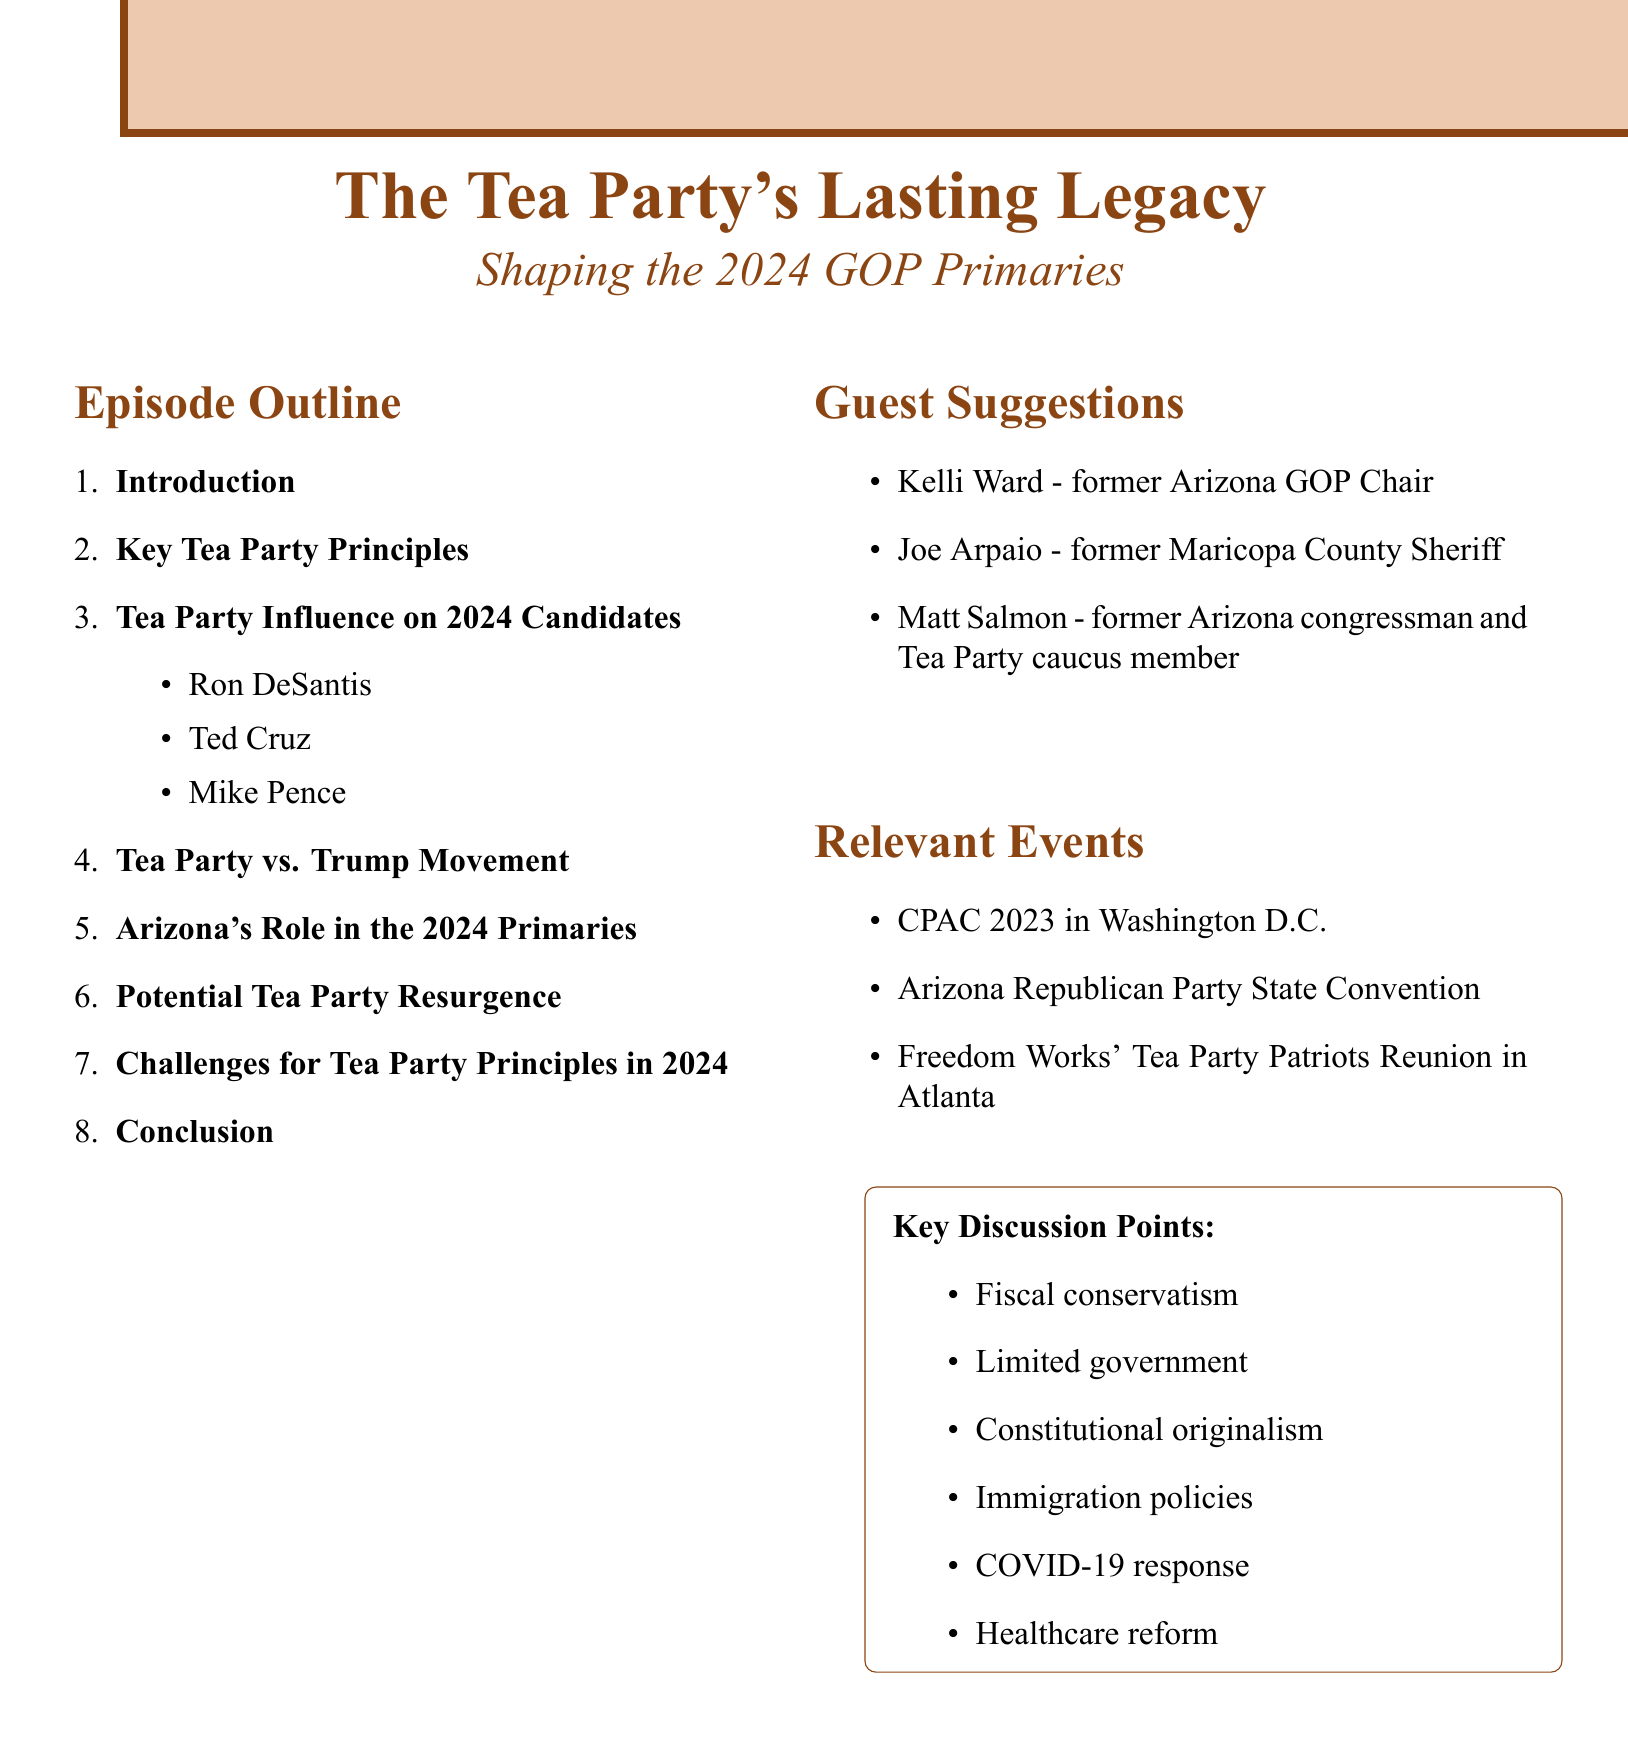What is the title of the podcast? The title of the podcast is presented as the main heading in the document.
Answer: The Tea Party's Lasting Legacy: Shaping the 2024 GOP Primaries How many candidates' influence are covered in the episode? The episode discusses the influence of three specific candidates on Tea Party principles.
Answer: Three Which key principle focuses on government size? The key principle that emphasizes the size of government can be found in the section discussing Tea Party values.
Answer: Limited government What is Arizona's status mentioned in the outline? The outline refers to Arizona's relevance in terms of its electoral role in the primaries.
Answer: Key swing state status Who is suggested as a guest who is a former Maricopa County Sheriff? One of the suggested guests is noted for their past position in local law enforcement.
Answer: Joe Arpaio What are the main themes discussed regarding challenges for the Tea Party in 2024? The themes highlight the difficulties the Tea Party faces as indicated in the relevant section.
Answer: Balancing fiscal conservatism with populist demands How many topics are covered in the introduction section? The introduction section lists three points of discussion.
Answer: Three What event is noted as taking place in Washington D.C.? The document includes a notable Republican gathering that occurred in the capital.
Answer: CPAC 2023 